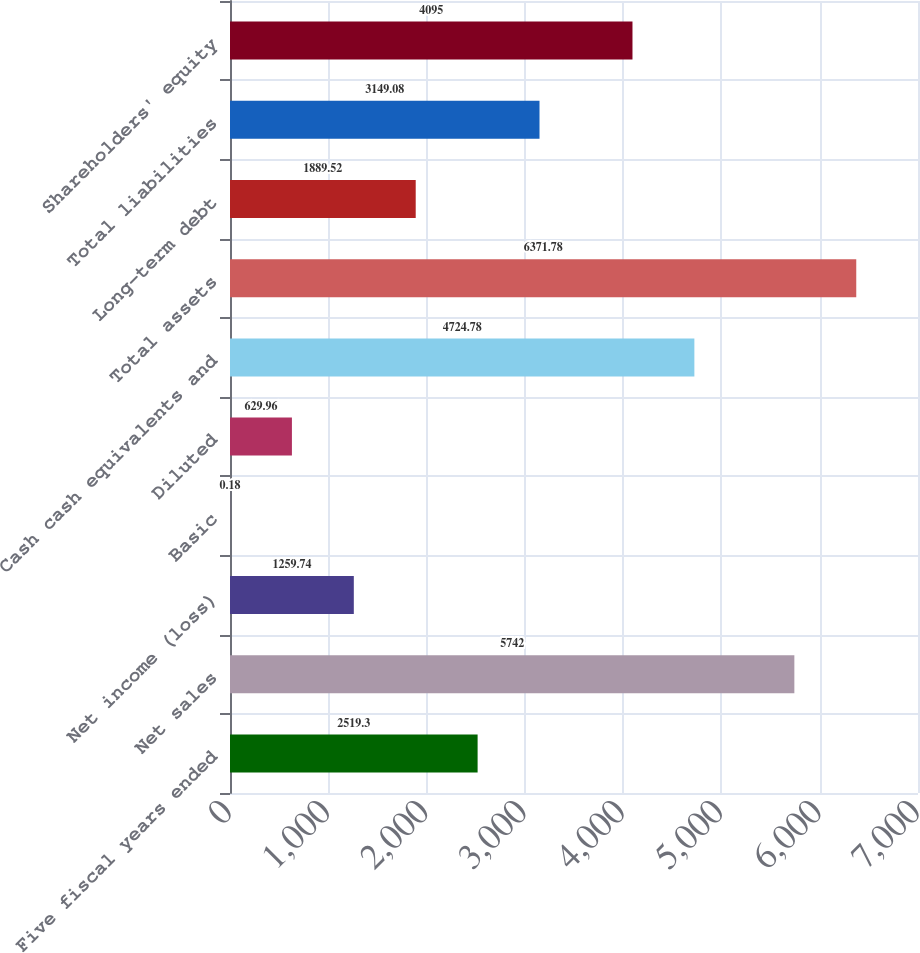<chart> <loc_0><loc_0><loc_500><loc_500><bar_chart><fcel>Five fiscal years ended<fcel>Net sales<fcel>Net income (loss)<fcel>Basic<fcel>Diluted<fcel>Cash cash equivalents and<fcel>Total assets<fcel>Long-term debt<fcel>Total liabilities<fcel>Shareholders' equity<nl><fcel>2519.3<fcel>5742<fcel>1259.74<fcel>0.18<fcel>629.96<fcel>4724.78<fcel>6371.78<fcel>1889.52<fcel>3149.08<fcel>4095<nl></chart> 